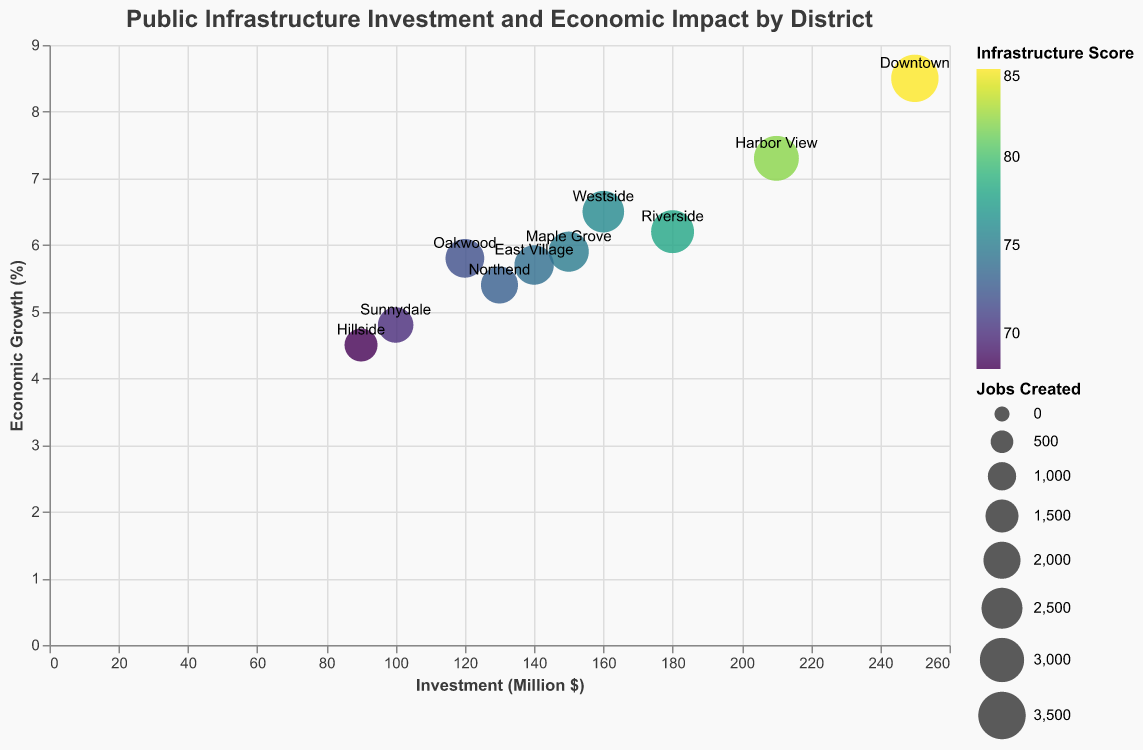What is the district with the highest investment in public infrastructure? The district with the highest investment can be identified by looking at the data points on the x-axis, which represents Investment (Million $). The district with the data point furthest to the right will have the highest investment. This is "Downtown" with an investment of $250 million.
Answer: Downtown Which district has the lowest economic growth percentage? The district with the lowest economic growth can be found by looking at the y-axis, which represents Economic Growth (%). The district with the data point closest to the bottom has the lowest economic growth percentage. This is "Hillside" with 4.5%.
Answer: Hillside What is the relationship between investment amount and economic growth for Downtown? By locating the data point for Downtown on the plot, one can observe its coordinates on both the x and y axes. Downtown has an investment of $250 million and an economic growth rate of 8.5%, suggesting a positive relationship between higher investment and higher economic growth.
Answer: Positive correlation Which districts have a higher Infrastructure Score than Northend? To identify districts with a higher Infrastructure Score than Northend, which has a score of 73, compare their color shades on the plot. Districts with a lighter color according to the viridis color scale have higher scores. These districts are Downtown, Riverside, Harbor View, Maple Grove, and Westside.
Answer: Downtown, Riverside, Harbor View, Maple Grove, Westside How many jobs were created in the district with the highest Infrastructure Score? The district with the highest Infrastructure Score can be identified by the color shade with the lightest hue. Downtown has the highest score of 85. The number of jobs created can be seen in the size of the data point, and in the tooltip, which shows 3,500 jobs created.
Answer: 3,500 Compare the economic growth rates of Riverside and Westside. Which one has a higher rate? To compare, locate the data points for Riverside and Westside on the plot. Riverside has a growth rate of 6.2%, whereas Westside has a rate of 6.5%. Therefore, Westside has a higher economic growth rate than Riverside.
Answer: Westside Calculate the average economic growth of East Village, Sunnydale, and Maple Grove. First, locate the economic growth percentages for East Village (5.7%), Sunnydale (4.8%), and Maple Grove (5.9%). Calculate the average: (5.7 + 4.8 + 5.9) / 3 = 5.47%.
Answer: 5.47% How does the investment in Northend compare to that in Oakwood? To compare their investments, find the data points on the x-axis. Northend has an investment of $130 million, and Oakwood has $120 million. Northend has a higher investment amount.
Answer: Northend What is the infrastructure score of the district with 2,600 jobs created? Locate the district that has created 2,600 jobs by finding the corresponding size in the plot. This is Westside. The tooltip shows that Westside has an Infrastructure Score of 76.
Answer: 76 Which district has the smallest circle size and what does it signify? The smallest circle size represents the district with the fewest jobs created. In the plot, the smallest circle corresponds to Hillside, which created 1,500 jobs.
Answer: Hillside 